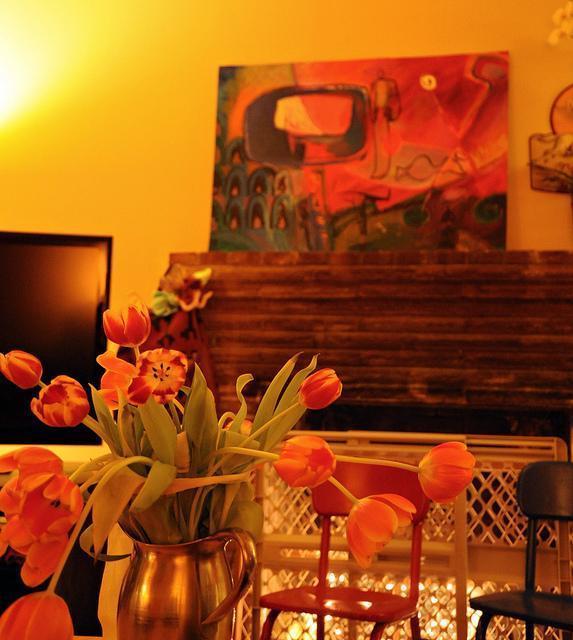How many vases are in the picture?
Give a very brief answer. 1. How many tvs are there?
Give a very brief answer. 2. How many chairs are visible?
Give a very brief answer. 2. 